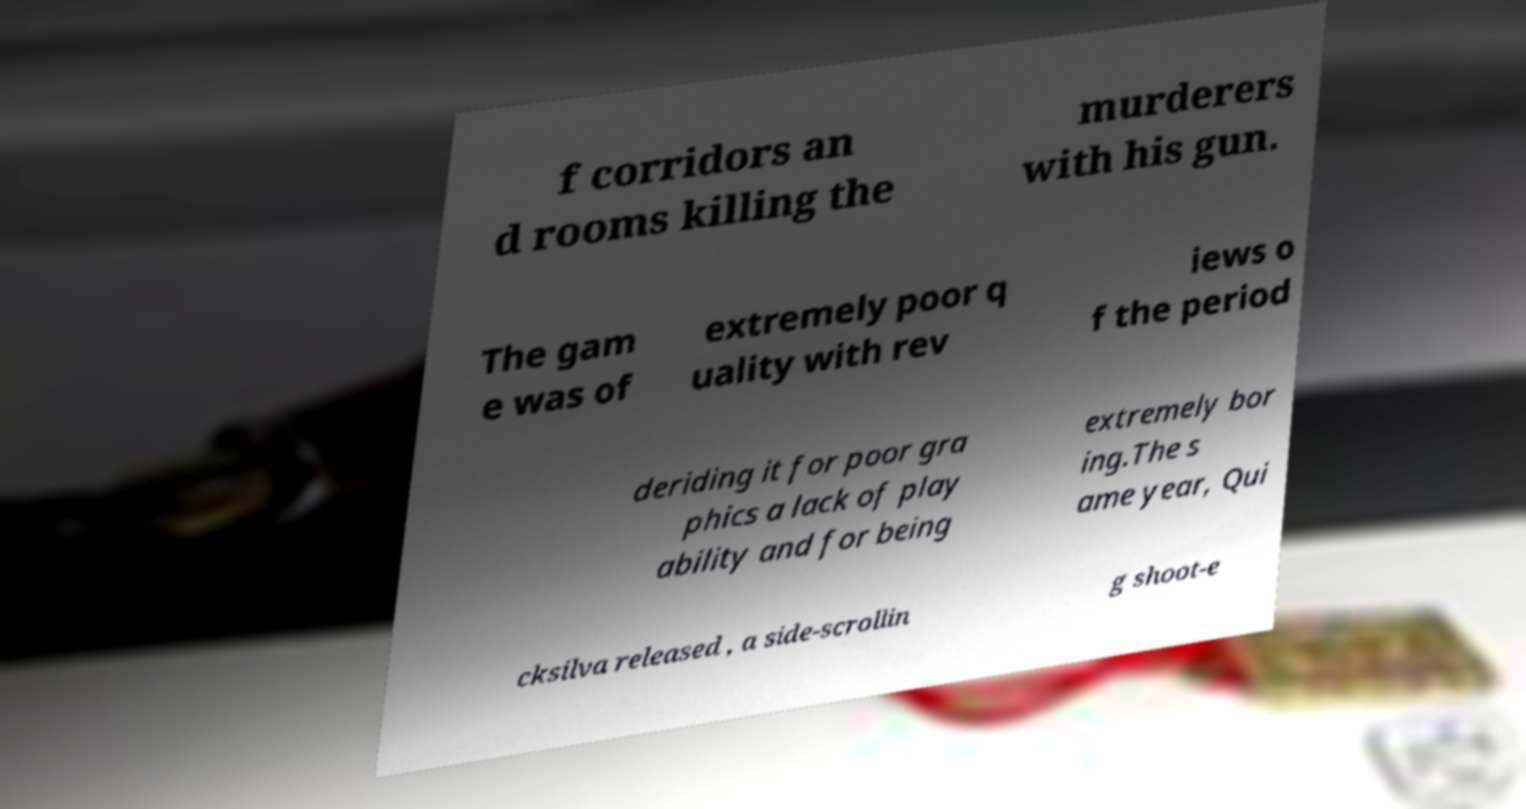There's text embedded in this image that I need extracted. Can you transcribe it verbatim? f corridors an d rooms killing the murderers with his gun. The gam e was of extremely poor q uality with rev iews o f the period deriding it for poor gra phics a lack of play ability and for being extremely bor ing.The s ame year, Qui cksilva released , a side-scrollin g shoot-e 